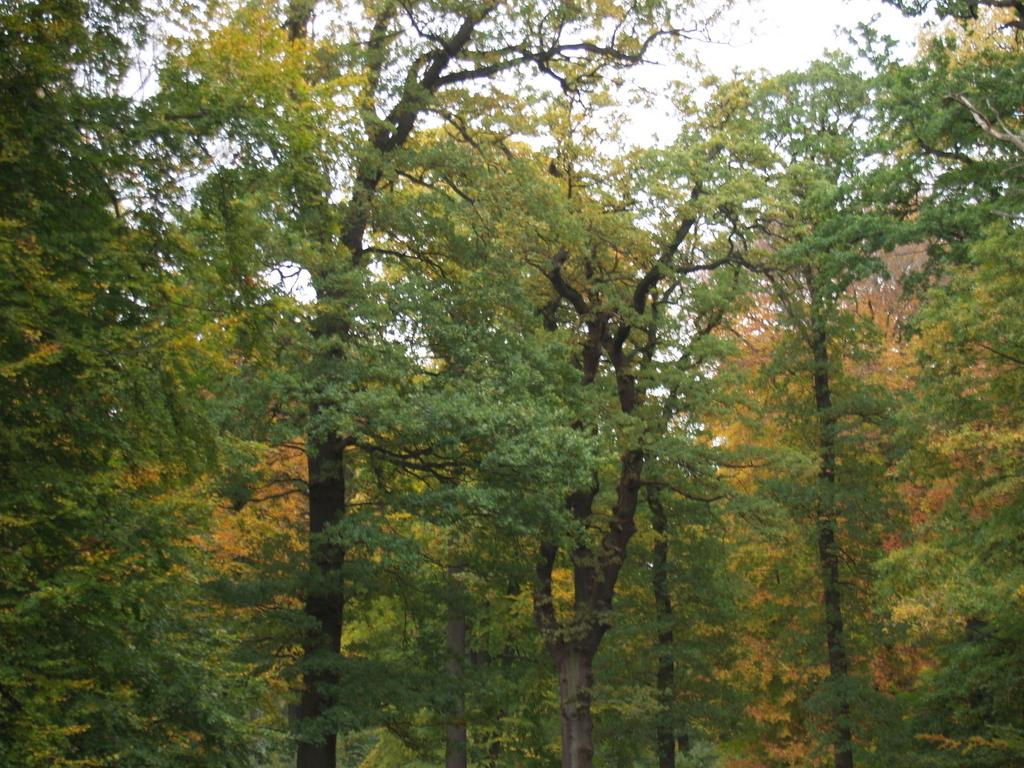What type of vegetation can be seen in the image? There are trees in the image. What part of the natural environment is visible in the image? The sky is visible in the image. How many chairs are placed around the group in the image? There are no chairs or groups present in the image; it only features trees and the sky. 